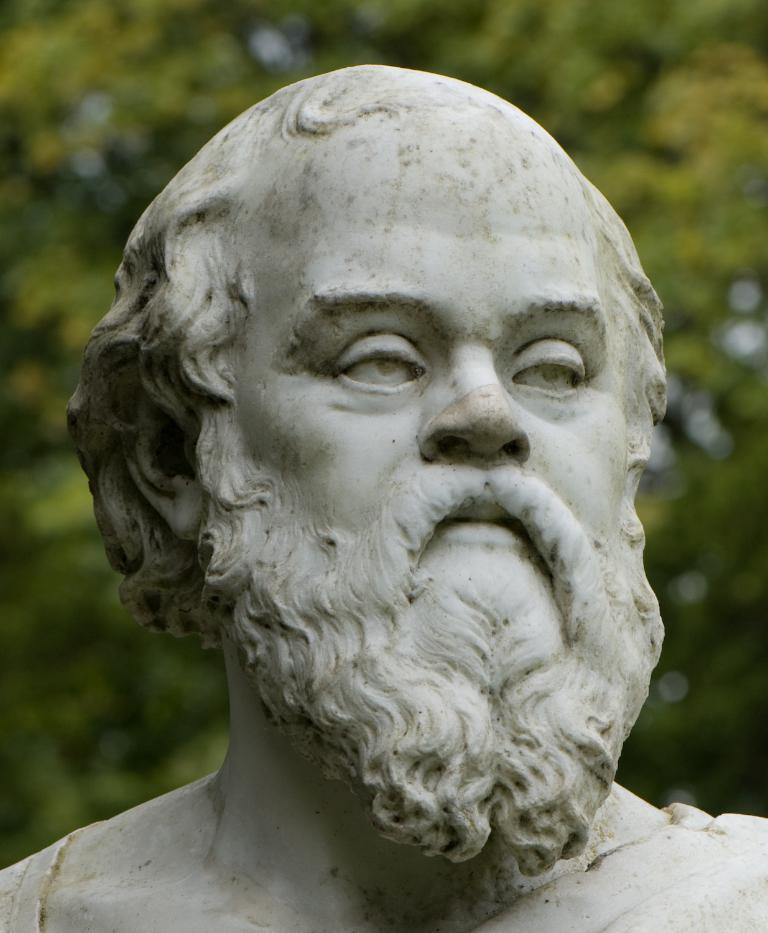What is the main subject in the center of the image? There is a statue in the center of the image. Can you describe the background of the image? The background of the image is blurred. What type of meal is being served in the church in the image? There is no church or meal present in the image; it features a statue with a blurred background. What is inside the jar that is visible in the image? There is no jar present in the image. 